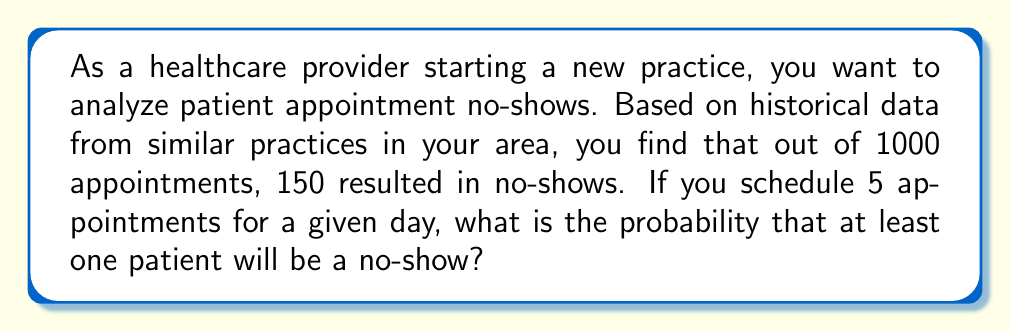Show me your answer to this math problem. To solve this problem, we'll use the following steps:

1. Calculate the probability of a single patient showing up:
   $$P(\text{show}) = 1 - P(\text{no-show}) = 1 - \frac{150}{1000} = 0.85$$

2. Calculate the probability of all 5 patients showing up:
   $$P(\text{all show}) = (0.85)^5 \approx 0.4437$$

3. The probability of at least one no-show is the complement of all patients showing up:
   $$P(\text{at least one no-show}) = 1 - P(\text{all show})$$
   $$= 1 - 0.4437 \approx 0.5563$$

We can also solve this using the binomial probability formula:

$$P(X \geq 1) = 1 - P(X = 0)$$

Where $X$ is the number of no-shows, $n = 5$ (number of appointments), and $p = 0.15$ (probability of a no-show).

$$P(X = 0) = \binom{5}{0} (0.15)^0 (0.85)^5 \approx 0.4437$$

$$P(X \geq 1) = 1 - 0.4437 \approx 0.5563$$

This confirms our earlier calculation.
Answer: The probability that at least one patient will be a no-show for a day with 5 scheduled appointments is approximately 0.5563 or 55.63%. 